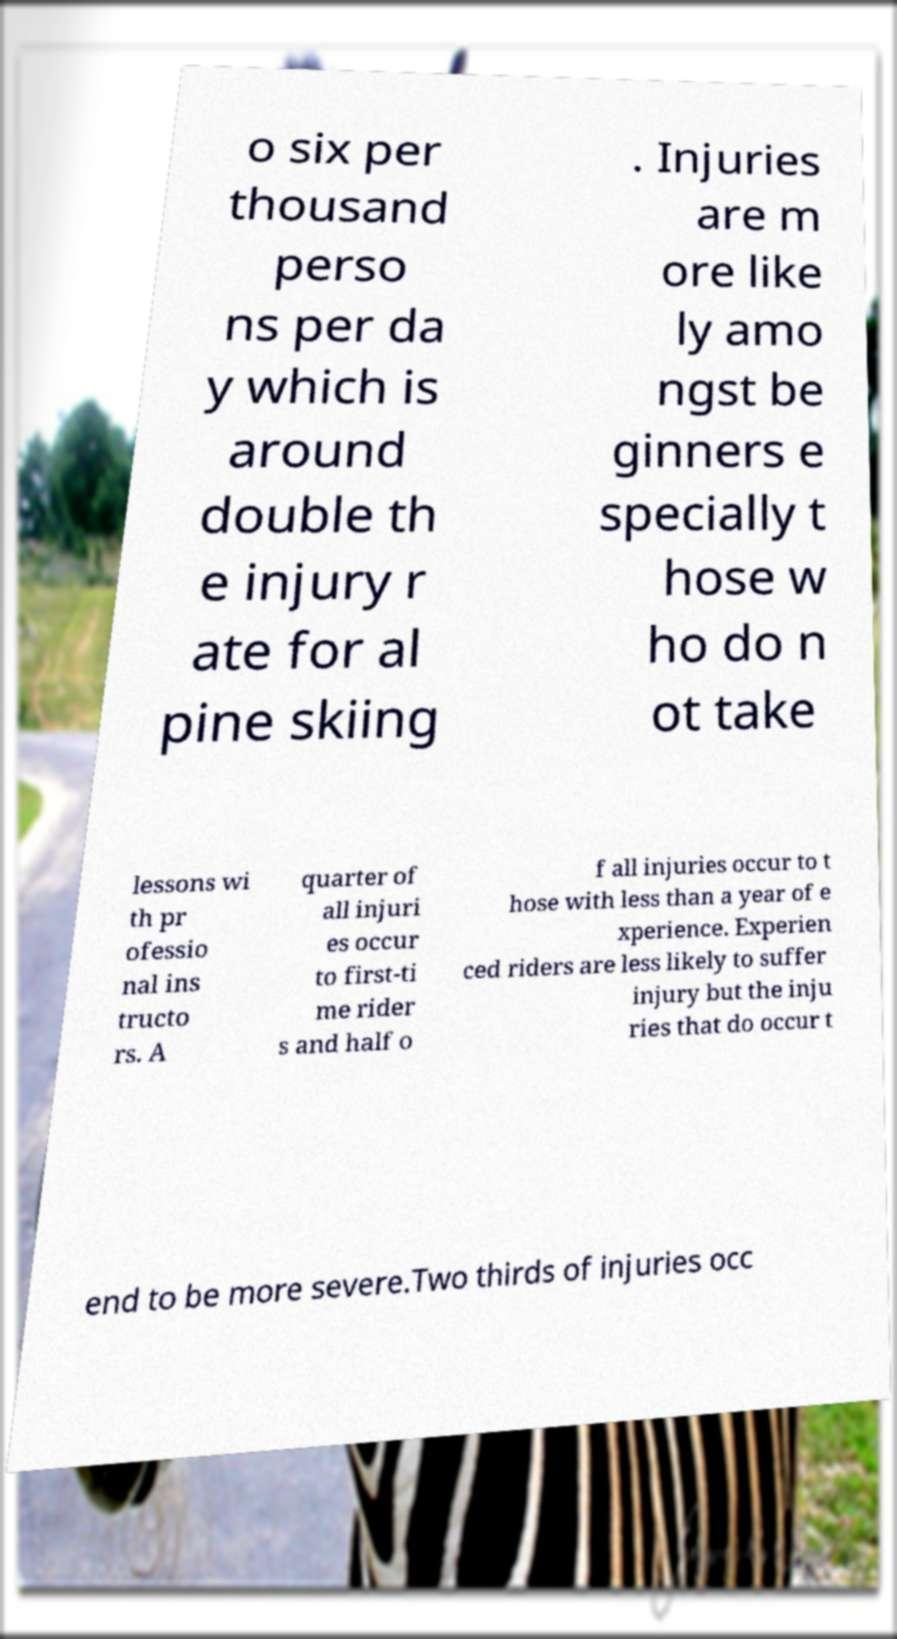Could you extract and type out the text from this image? o six per thousand perso ns per da y which is around double th e injury r ate for al pine skiing . Injuries are m ore like ly amo ngst be ginners e specially t hose w ho do n ot take lessons wi th pr ofessio nal ins tructo rs. A quarter of all injuri es occur to first-ti me rider s and half o f all injuries occur to t hose with less than a year of e xperience. Experien ced riders are less likely to suffer injury but the inju ries that do occur t end to be more severe.Two thirds of injuries occ 